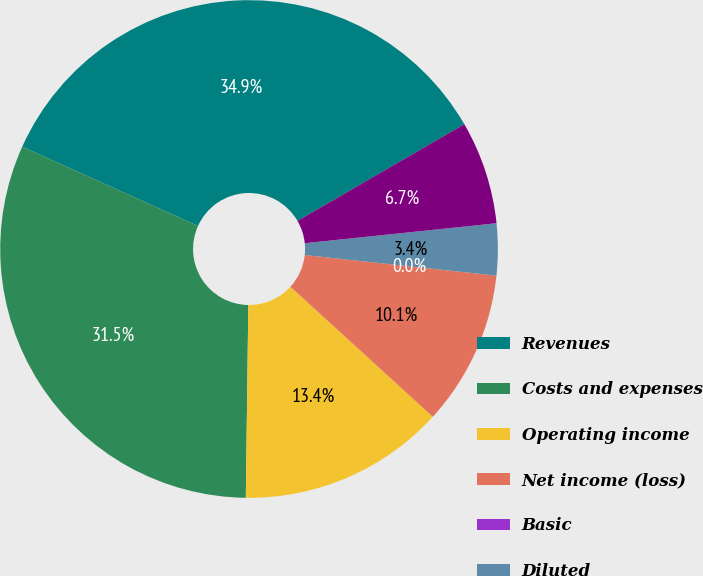Convert chart. <chart><loc_0><loc_0><loc_500><loc_500><pie_chart><fcel>Revenues<fcel>Costs and expenses<fcel>Operating income<fcel>Net income (loss)<fcel>Basic<fcel>Diluted<fcel>Net income<nl><fcel>34.9%<fcel>31.54%<fcel>13.43%<fcel>10.07%<fcel>0.0%<fcel>3.36%<fcel>6.71%<nl></chart> 